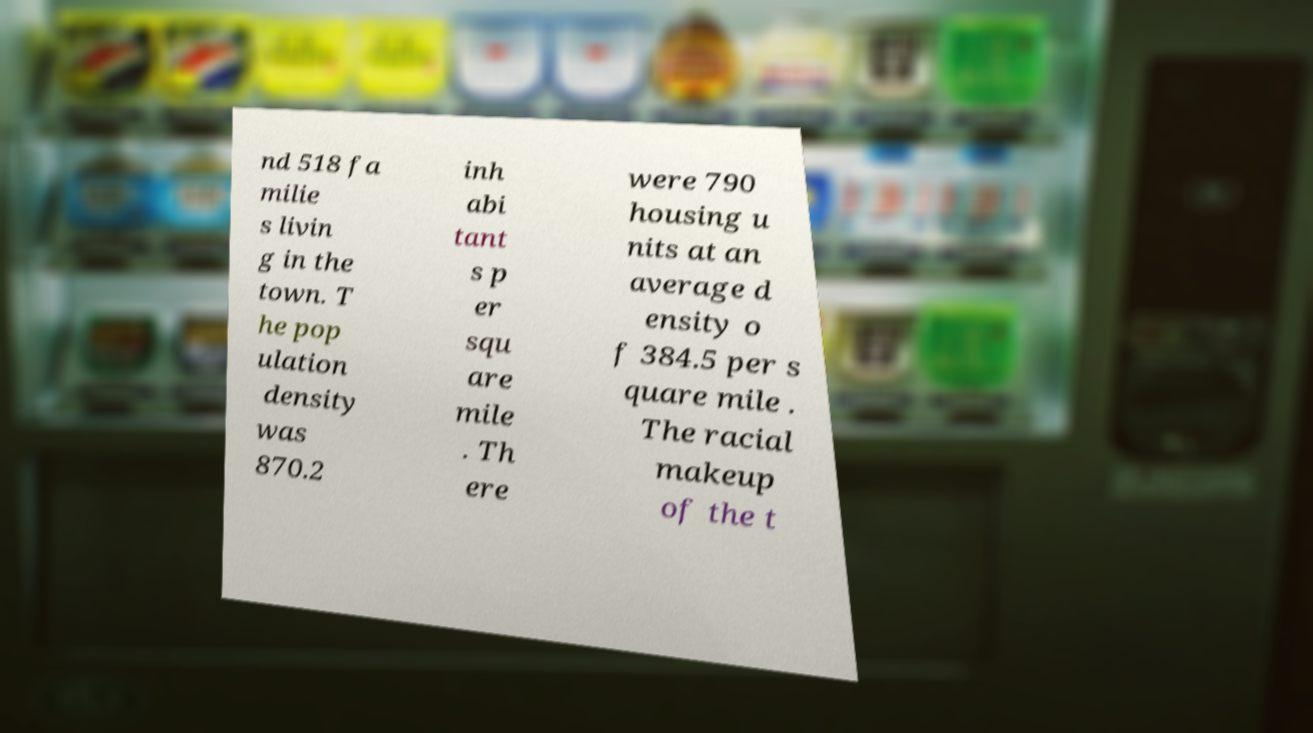Could you extract and type out the text from this image? nd 518 fa milie s livin g in the town. T he pop ulation density was 870.2 inh abi tant s p er squ are mile . Th ere were 790 housing u nits at an average d ensity o f 384.5 per s quare mile . The racial makeup of the t 